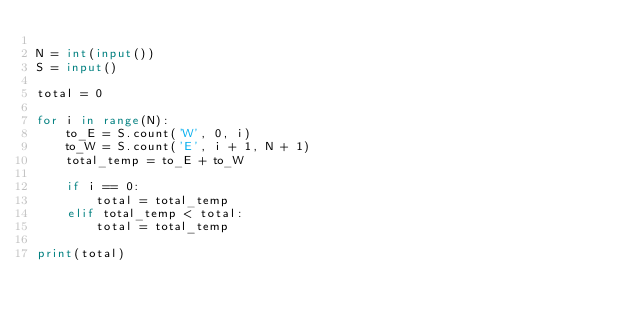Convert code to text. <code><loc_0><loc_0><loc_500><loc_500><_Python_>
N = int(input())
S = input()

total = 0

for i in range(N):
    to_E = S.count('W', 0, i)
    to_W = S.count('E', i + 1, N + 1)
    total_temp = to_E + to_W

    if i == 0:
        total = total_temp
    elif total_temp < total:
        total = total_temp

print(total)
</code> 